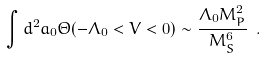<formula> <loc_0><loc_0><loc_500><loc_500>\int d ^ { 2 } a _ { 0 } \Theta ( - \Lambda _ { 0 } < V < 0 ) \sim \frac { \Lambda _ { 0 } M _ { P } ^ { 2 } } { M _ { S } ^ { 6 } } \ .</formula> 